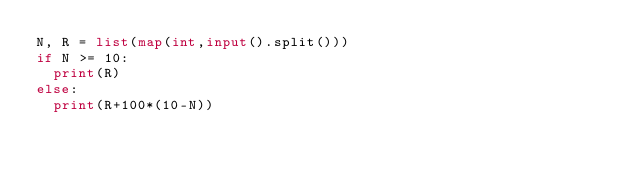Convert code to text. <code><loc_0><loc_0><loc_500><loc_500><_Python_>N, R = list(map(int,input().split()))
if N >= 10:
  print(R)
else:
  print(R+100*(10-N))</code> 